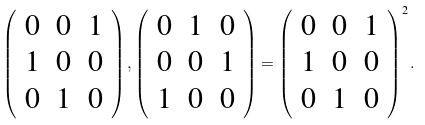<formula> <loc_0><loc_0><loc_500><loc_500>\left ( \begin{array} { c c c } 0 & 0 & 1 \\ 1 & 0 & 0 \\ 0 & 1 & 0 \\ \end{array} \right ) , \left ( \begin{array} { c c c } 0 & 1 & 0 \\ 0 & 0 & 1 \\ 1 & 0 & 0 \\ \end{array} \right ) = \left ( \begin{array} { c c c } 0 & 0 & 1 \\ 1 & 0 & 0 \\ 0 & 1 & 0 \\ \end{array} \right ) ^ { 2 } .</formula> 